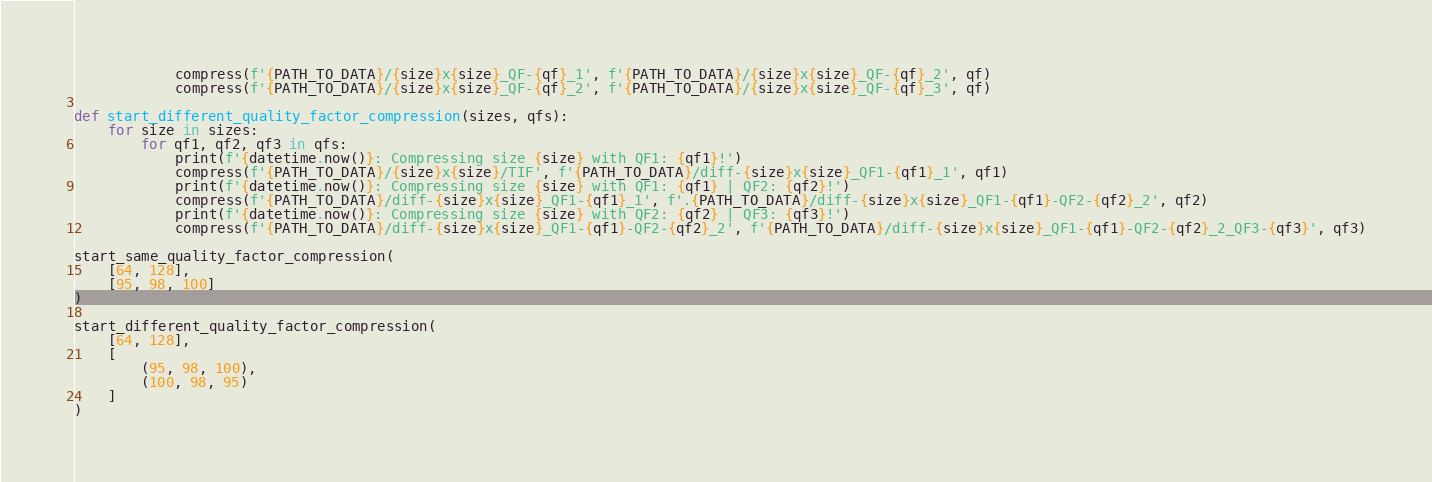Convert code to text. <code><loc_0><loc_0><loc_500><loc_500><_Python_>            compress(f'{PATH_TO_DATA}/{size}x{size}_QF-{qf}_1', f'{PATH_TO_DATA}/{size}x{size}_QF-{qf}_2', qf)
            compress(f'{PATH_TO_DATA}/{size}x{size}_QF-{qf}_2', f'{PATH_TO_DATA}/{size}x{size}_QF-{qf}_3', qf)

def start_different_quality_factor_compression(sizes, qfs):
    for size in sizes:
        for qf1, qf2, qf3 in qfs:
            print(f'{datetime.now()}: Compressing size {size} with QF1: {qf1}!')
            compress(f'{PATH_TO_DATA}/{size}x{size}/TIF', f'{PATH_TO_DATA}/diff-{size}x{size}_QF1-{qf1}_1', qf1)
            print(f'{datetime.now()}: Compressing size {size} with QF1: {qf1} | QF2: {qf2}!')
            compress(f'{PATH_TO_DATA}/diff-{size}x{size}_QF1-{qf1}_1', f'.{PATH_TO_DATA}/diff-{size}x{size}_QF1-{qf1}-QF2-{qf2}_2', qf2)
            print(f'{datetime.now()}: Compressing size {size} with QF2: {qf2} | QF3: {qf3}!')
            compress(f'{PATH_TO_DATA}/diff-{size}x{size}_QF1-{qf1}-QF2-{qf2}_2', f'{PATH_TO_DATA}/diff-{size}x{size}_QF1-{qf1}-QF2-{qf2}_2_QF3-{qf3}', qf3)

start_same_quality_factor_compression(
    [64, 128],
    [95, 98, 100]
)

start_different_quality_factor_compression(
    [64, 128],
    [
        (95, 98, 100),
        (100, 98, 95)
    ]
)
</code> 